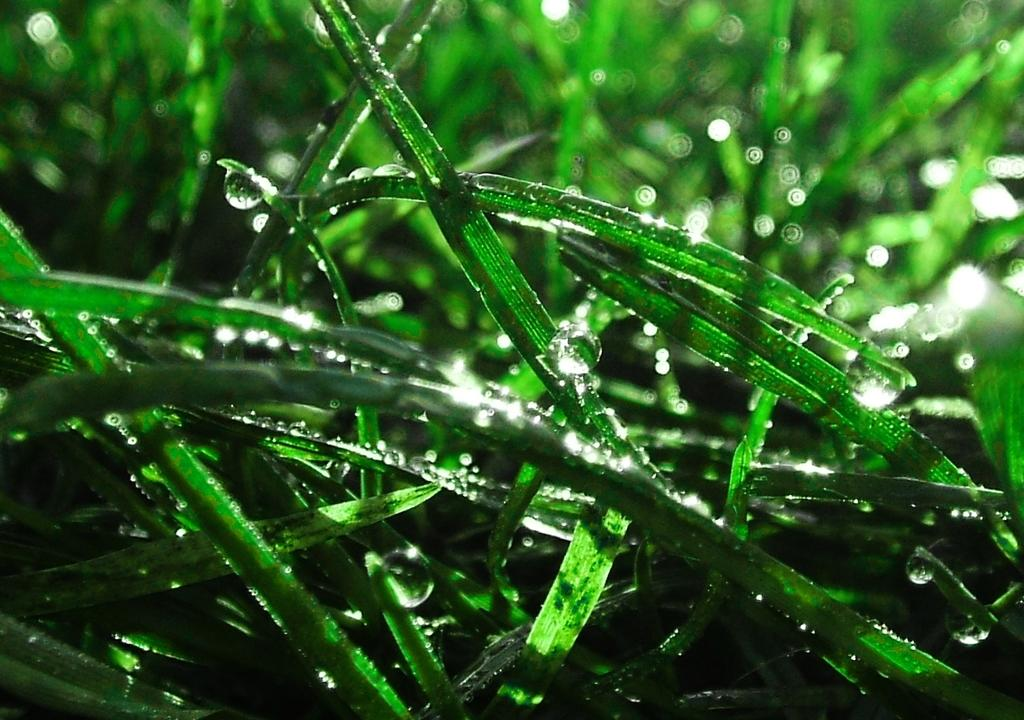What type of vegetation can be seen in the image? There is green grass in the image. What else is present in the image besides the green grass? Water droplets are visible in the image. Are there any fairies flying around the green grass in the image? There is no indication of fairies in the image; it only shows green grass and water droplets. 